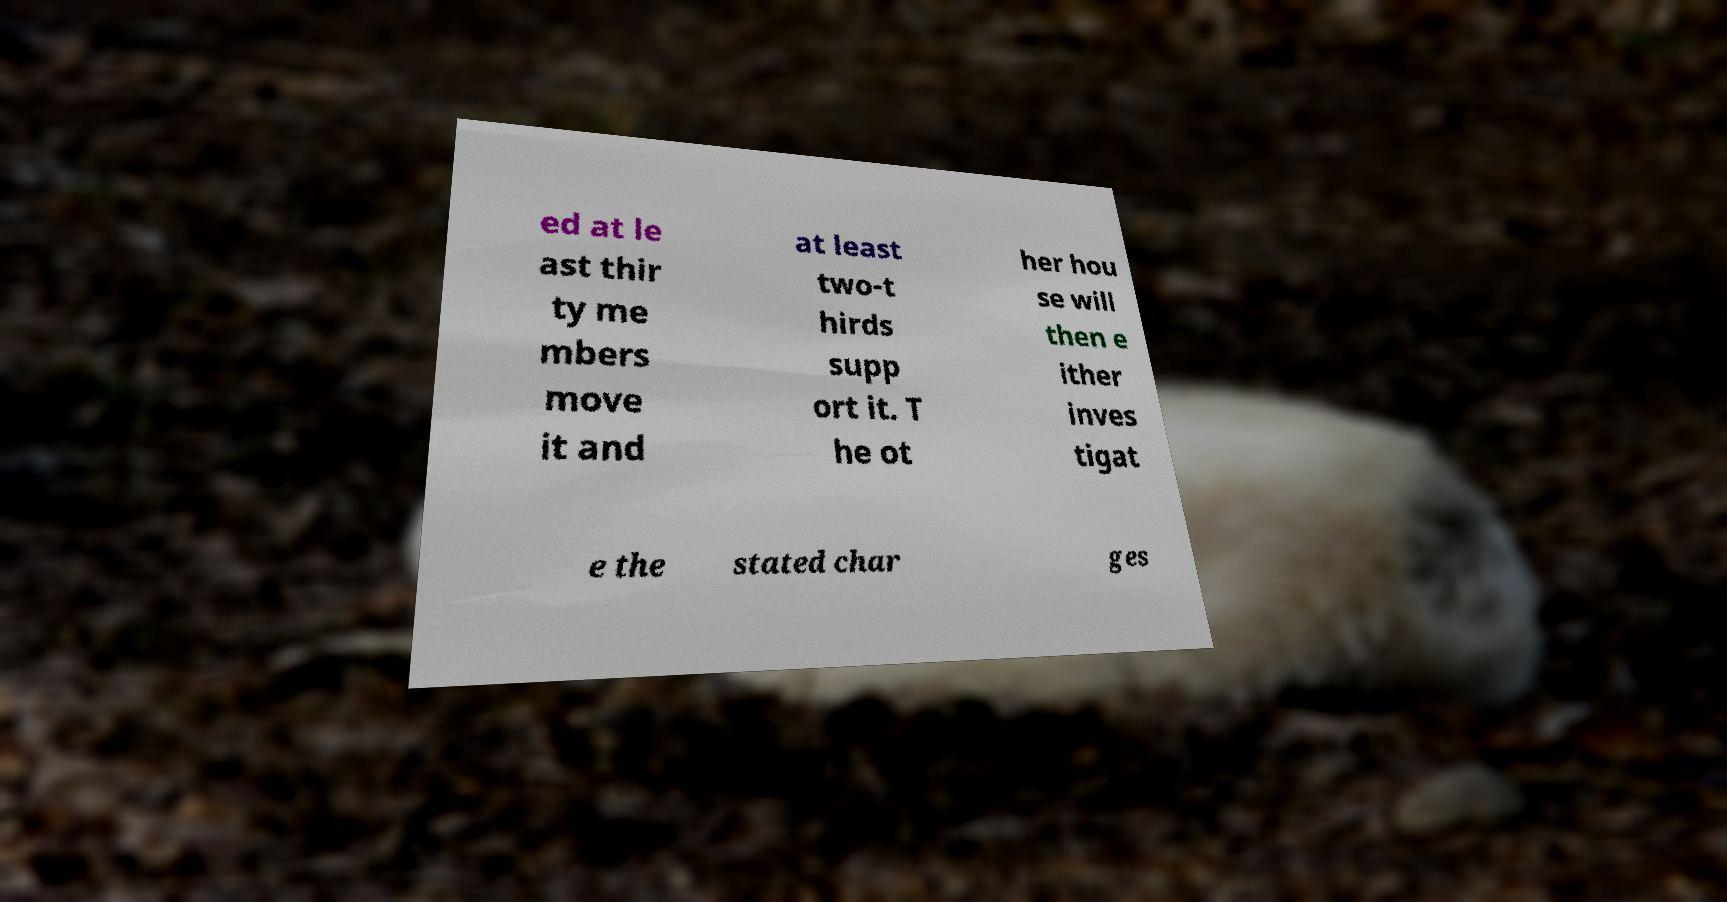Can you accurately transcribe the text from the provided image for me? ed at le ast thir ty me mbers move it and at least two-t hirds supp ort it. T he ot her hou se will then e ither inves tigat e the stated char ges 